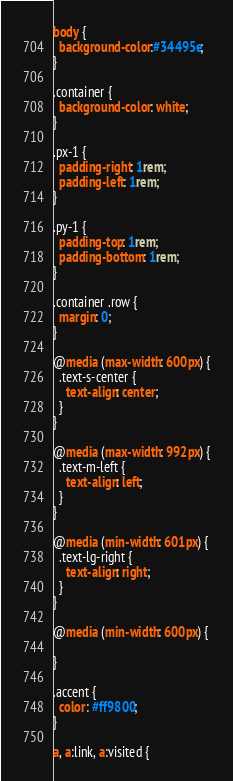<code> <loc_0><loc_0><loc_500><loc_500><_CSS_>body {
  background-color:#34495e;
}

.container {
  background-color: white;
}

.px-1 {
  padding-right: 1rem;
  padding-left: 1rem;  
}

.py-1 {
  padding-top: 1rem;
  padding-bottom: 1rem;  
}

.container .row {
  margin: 0;
}

@media (max-width: 600px) {
  .text-s-center {
    text-align: center;
  }
}

@media (max-width: 992px) {
  .text-m-left {
    text-align: left;
  }
}

@media (min-width: 601px) {
  .text-lg-right {
    text-align: right;
  }
}

@media (min-width: 600px) {

}

.accent {
  color: #ff9800;
}

a, a:link, a:visited {</code> 